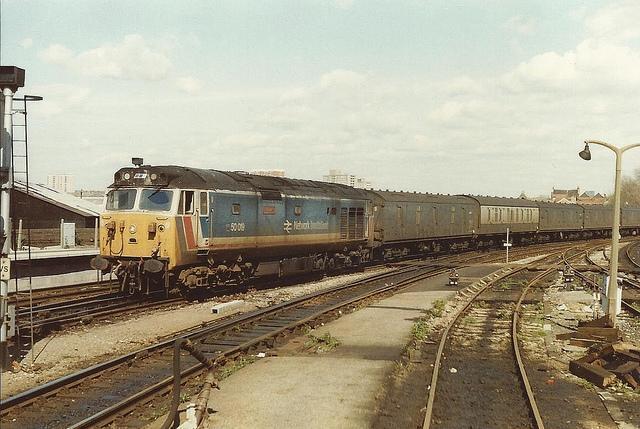How many trains can you see?
Give a very brief answer. 1. 